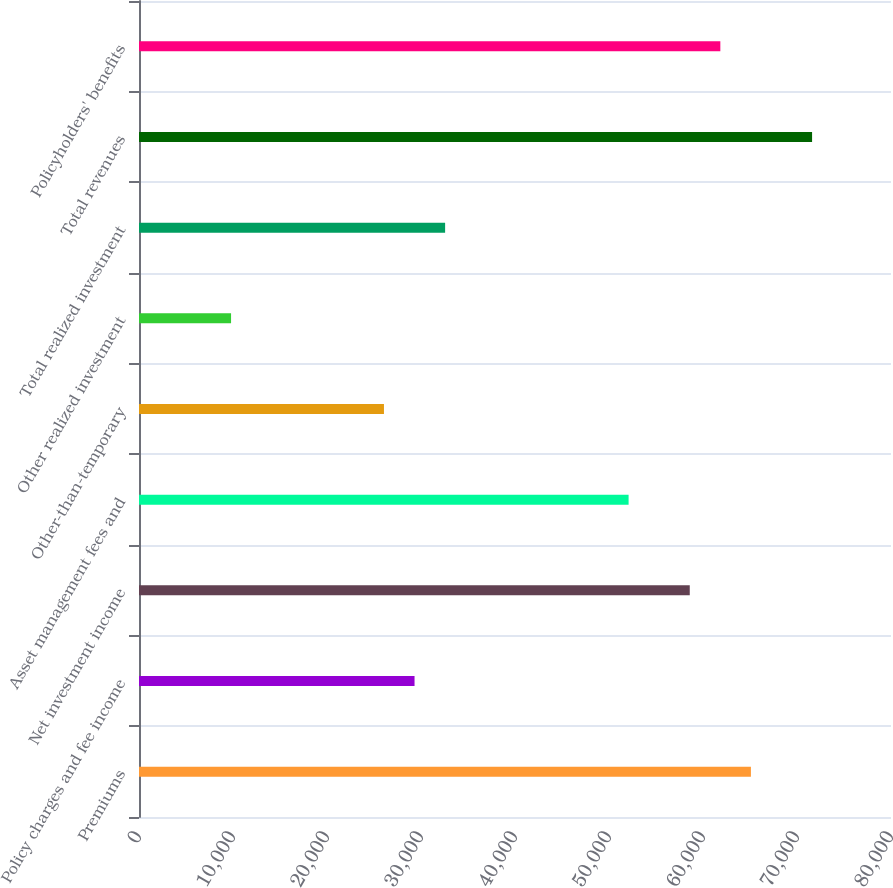Convert chart. <chart><loc_0><loc_0><loc_500><loc_500><bar_chart><fcel>Premiums<fcel>Policy charges and fee income<fcel>Net investment income<fcel>Asset management fees and<fcel>Other-than-temporary<fcel>Other realized investment<fcel>Total realized investment<fcel>Total revenues<fcel>Policyholders' benefits<nl><fcel>65098<fcel>29312.8<fcel>58591.6<fcel>52085.2<fcel>26059.6<fcel>9793.6<fcel>32566<fcel>71604.4<fcel>61844.8<nl></chart> 